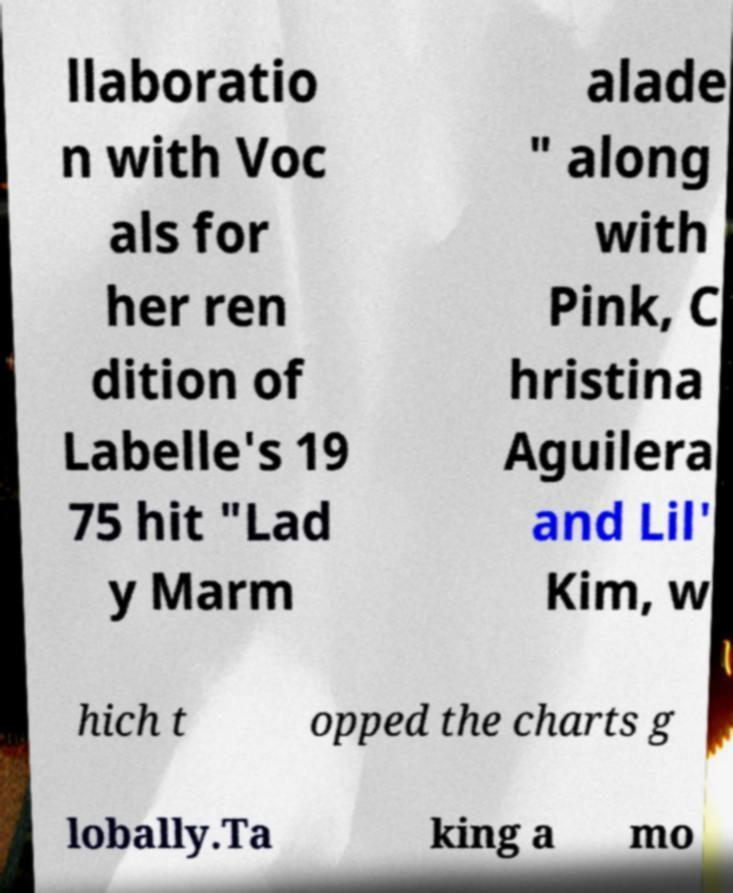For documentation purposes, I need the text within this image transcribed. Could you provide that? llaboratio n with Voc als for her ren dition of Labelle's 19 75 hit "Lad y Marm alade " along with Pink, C hristina Aguilera and Lil' Kim, w hich t opped the charts g lobally.Ta king a mo 